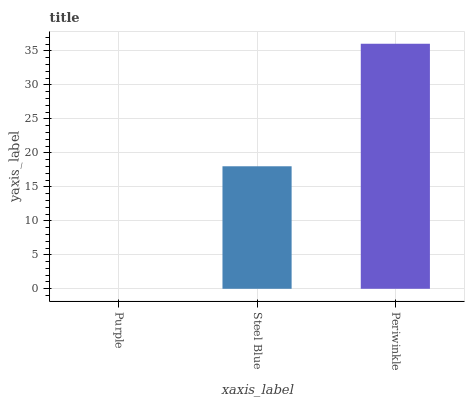Is Purple the minimum?
Answer yes or no. Yes. Is Periwinkle the maximum?
Answer yes or no. Yes. Is Steel Blue the minimum?
Answer yes or no. No. Is Steel Blue the maximum?
Answer yes or no. No. Is Steel Blue greater than Purple?
Answer yes or no. Yes. Is Purple less than Steel Blue?
Answer yes or no. Yes. Is Purple greater than Steel Blue?
Answer yes or no. No. Is Steel Blue less than Purple?
Answer yes or no. No. Is Steel Blue the high median?
Answer yes or no. Yes. Is Steel Blue the low median?
Answer yes or no. Yes. Is Periwinkle the high median?
Answer yes or no. No. Is Purple the low median?
Answer yes or no. No. 